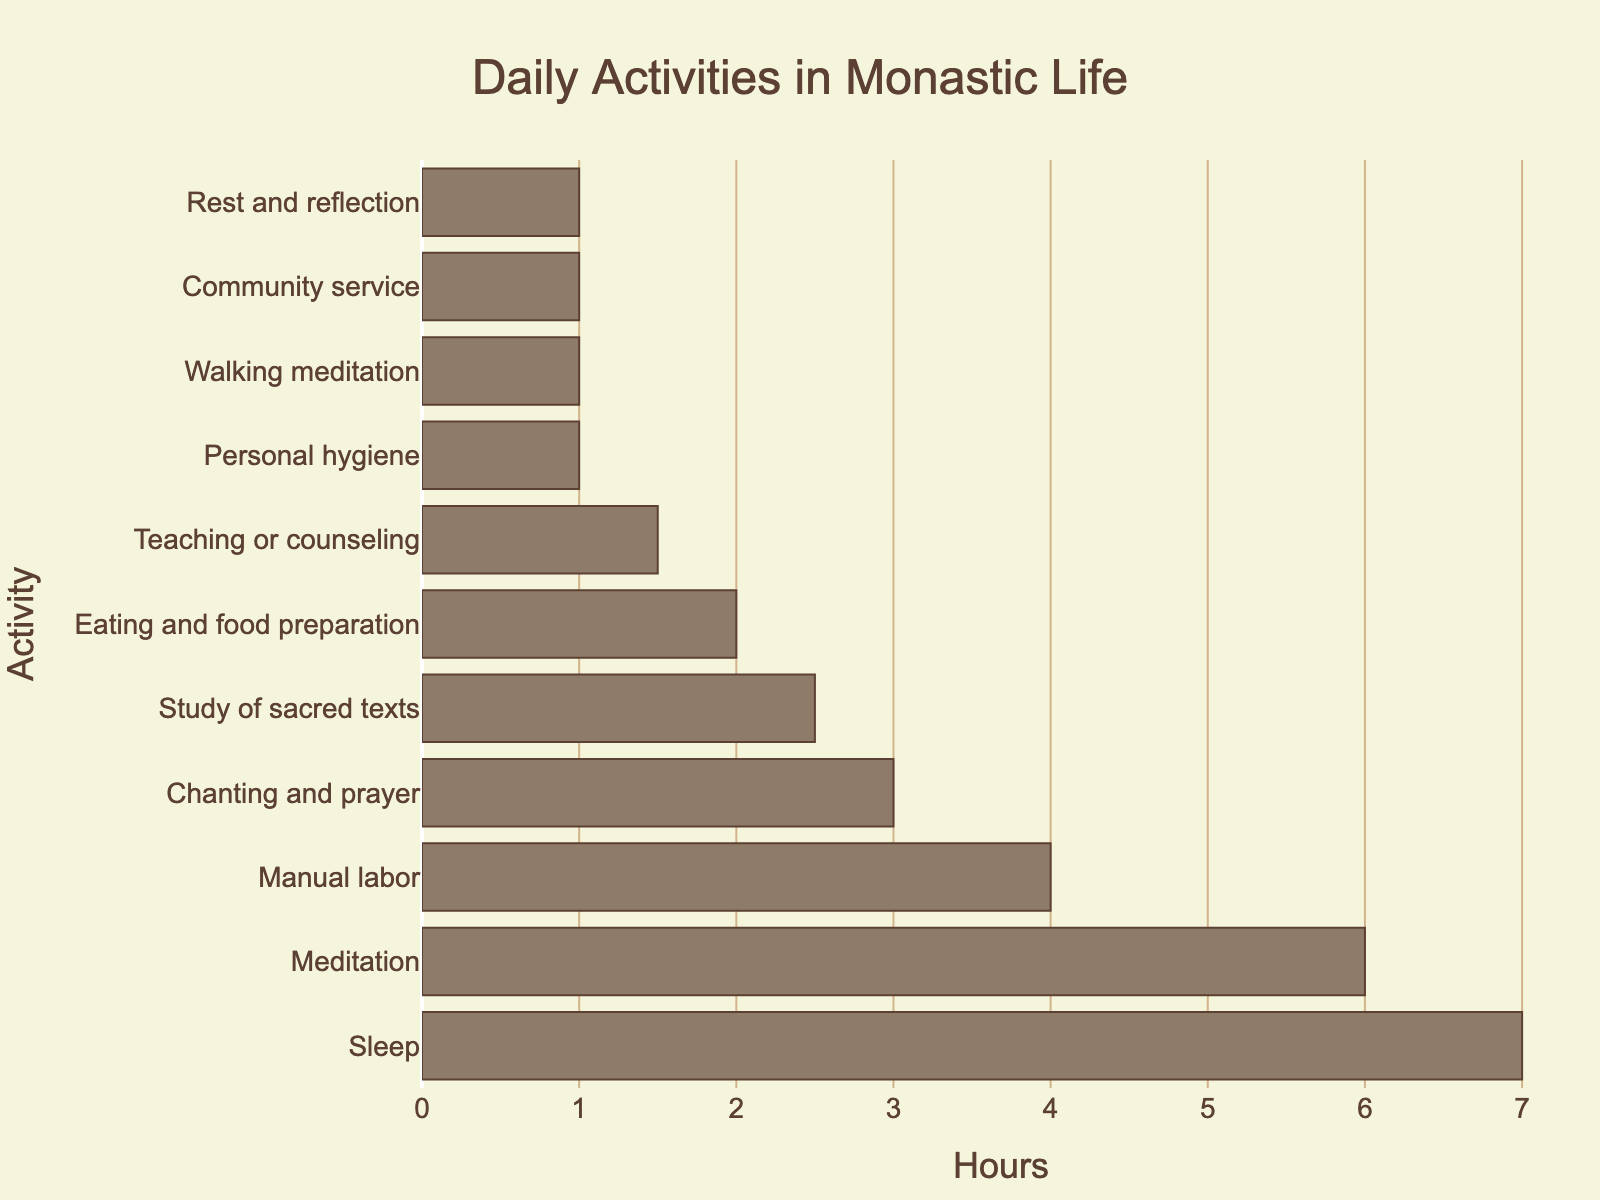Which activity takes up the most hours? The activity with the longest bar corresponds to the one taking up the most hours. In this case, the "Sleep" bar is the longest.
Answer: Sleep How many hours in total are spent on "Meditation" and "Manual labor"? Add the hours for "Meditation" (6 hours) and "Manual labor" (4 hours) together: 6 + 4 = 10 hours.
Answer: 10 Which activity takes less time: "Chanting and prayer" or "Teaching or counseling"? Compare the lengths of the bars for "Chanting and prayer" (3 hours) and "Teaching or counseling" (1.5 hours). The "Teaching or counseling" bar is shorter.
Answer: Teaching or counseling What is the average time spent on "Eating and food preparation", "Personal hygiene", and "Rest and reflection"? Sum the hours for the three activities: 2 + 1 + 1 = 4 hours. Then, divide by the number of activities: 4/3 ≈ 1.33 hours.
Answer: 1.33 If you combine the hours spent on "Study of sacred texts" and "Walking meditation", how does this total compare to the hours spent on "Manual labor"? Add the hours for "Study of sacred texts" (2.5 hours) and "Walking meditation" (1 hour): 2.5 + 1 = 3.5 hours. Compare this to "Manual labor" (4 hours). 3.5 is less than 4.
Answer: Less What percentage of the day is spent on "Meditation"? "Meditation" takes 6 hours out of a 24-hour day. Calculate the percentage: (6/24) * 100 = 25%.
Answer: 25% Are the combined hours spent on "Chanting and prayer" and "Community service" more than those spent on "Meditation"? Add the hours for "Chanting and prayer" (3 hours) and "Community service" (1 hour): 3 + 1 = 4 hours. Compare this to "Meditation" (6 hours). 4 is less than 6.
Answer: No How many activities take between 1 and 2 hours? Count the activities with hourly values in this range: "Personal hygiene" (1), "Walking meditation" (1), "Community service" (1), and "Rest and reflection" (1). There are 4 such activities.
Answer: 4 